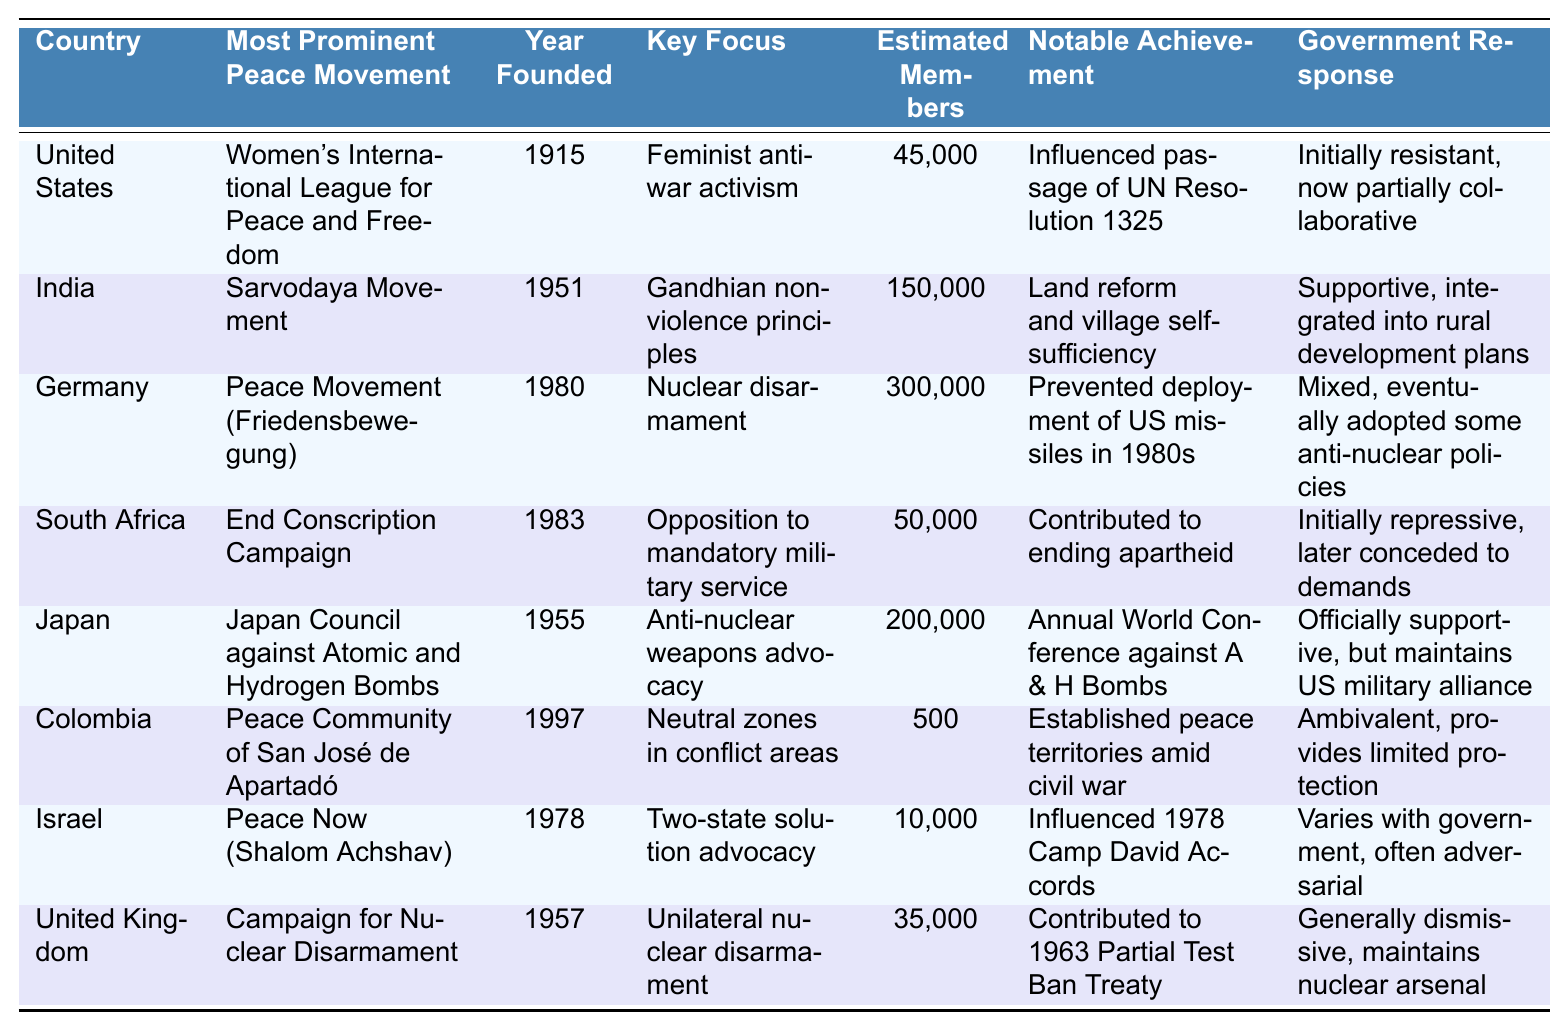What is the most prominent peace movement in India? Referring to the table, the most prominent peace movement in India is the Sarvodaya Movement.
Answer: Sarvodaya Movement Which peace movement was founded first, the Campaign for Nuclear Disarmament or the Women's International League for Peace and Freedom? The table indicates that the Women's International League for Peace and Freedom was founded in 1915 and the Campaign for Nuclear Disarmament in 1957, thus it was founded first.
Answer: Women's International League for Peace and Freedom How many estimated members does the Peace Movement in Germany have? Looking at the table, the estimated members of the Peace Movement (Friedensbewegung) in Germany is 300,000.
Answer: 300,000 Which country has a peace movement that focuses on Gandhian nonviolence principles? The table shows that the peace movement in India focuses on Gandhian nonviolence principles through the Sarvodaya Movement.
Answer: India What was a notable achievement of the Women's International League for Peace and Freedom? According to the table, the Women's International League for Peace and Freedom influenced the passage of UN Resolution 1325.
Answer: Influenced passage of UN Resolution 1325 Which country's peace movement has government support but also maintains a military alliance with the US? The table states that Japan's peace movement, the Japan Council against Atomic and Hydrogen Bombs, is officially supportive but maintains a US military alliance.
Answer: Japan What is the total estimated membership of the peace movements in the United States and the United Kingdom combined? From the table, the estimated members in the US is 45,000 and in the UK is 35,000. Adding these gives 45,000 + 35,000 = 80,000.
Answer: 80,000 Which peace movement was involved in contributing to ending apartheid in South Africa? The End Conscription Campaign in South Africa is mentioned in the table as contributing to ending apartheid.
Answer: End Conscription Campaign True or False: The Peace Community of San José de Apartadó was founded before the End Conscription Campaign. The table shows that the End Conscription Campaign was founded in 1983 and the Peace Community of San José de Apartadó in 1997, thus the statement is False.
Answer: False Which country has the smallest estimated membership in its peace movement? By reviewing the table, Colombia's Peace Community of San José de Apartadó has the smallest estimated membership with 500 members.
Answer: Colombia 